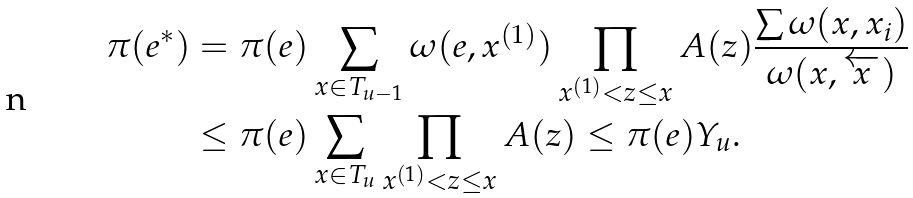<formula> <loc_0><loc_0><loc_500><loc_500>\pi ( e ^ { * } ) & = \pi ( e ) \sum _ { x \in T _ { u - 1 } } \omega ( e , x ^ { ( 1 ) } ) \prod _ { x ^ { ( 1 ) } < z \leq x } A ( z ) \frac { \sum \omega ( x , x _ { i } ) } { \omega ( x , \overleftarrow { x } ) } \\ & \leq \pi ( e ) \sum _ { x \in T _ { u } } \prod _ { x ^ { ( 1 ) } < z \leq x } A ( z ) \leq \pi ( e ) Y _ { u } .</formula> 